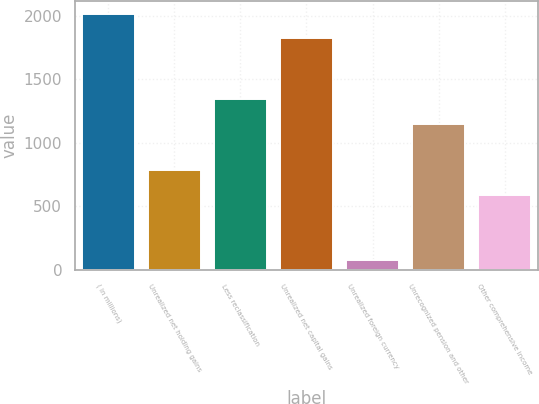<chart> <loc_0><loc_0><loc_500><loc_500><bar_chart><fcel>( in millions)<fcel>Unrealized net holding gains<fcel>Less reclassification<fcel>Unrealized net capital gains<fcel>Unrealized foreign currency<fcel>Unrecognized pension and other<fcel>Other comprehensive income<nl><fcel>2016.5<fcel>784.5<fcel>1342.5<fcel>1824<fcel>82<fcel>1150<fcel>592<nl></chart> 